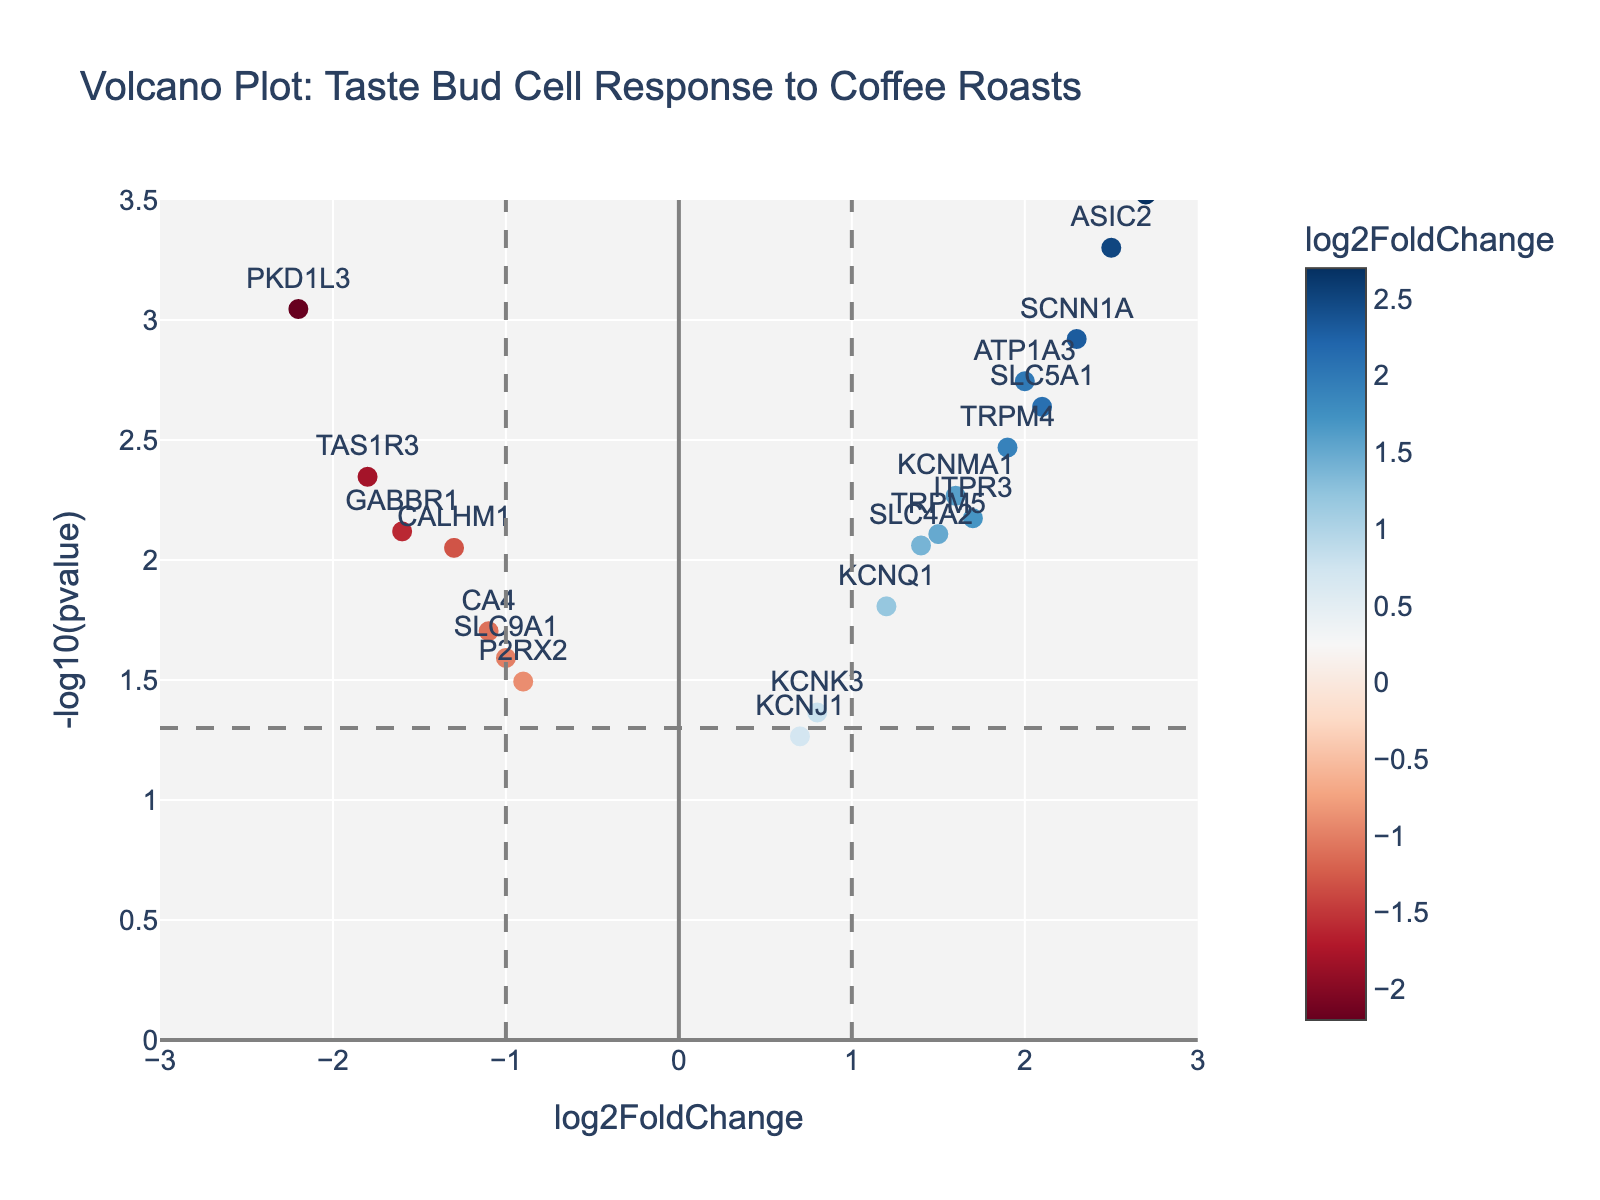what is the title of the plot? The title is usually displayed at the top of the plot and is the text that describes the overall topic or data being visualized.
Answer: Volcano Plot: Taste Bud Cell Response to Coffee Roasts how many genes have a p-value below 0.005? To answer this question, count the data points with -log10(pvalue) greater than log10(0.005), which is approximately 2.3.
Answer: Seven which gene has the highest log2FoldChange? Identify the data point with the highest log2FoldChange value.
Answer: GNAT3 what is the log2FoldChange for gene SCNN1A? Find the data point labeled SCNN1A and read its log2FoldChange value.
Answer: 2.3 what is the significance threshold in terms of -log10(pvalue) depicted by the dashed horizontal line? The dashed horizontal line marks the threshold for statistical significance in a volcano plot. This value corresponds to -log10(0.05).
Answer: 1.3 which genes are downregulated with a p-value less than 0.01? Identify genes with negative log2FoldChange and -log10(pvalue) above 2.
Answer: TAS1R3, PKD1L3, CALHM1, GABBR1 which gene has the most significant change? The most significant change is the gene with the highest -log10(pvalue).
Answer: GNAT3 how many genes have a log2FoldChange greater than 1 and a p-value less than 0.01? Count the data points with log2FoldChange > 1 and -log10(pvalue) > 2.
Answer: Five which gene is closest to the log2FoldChange threshold of -1? Identify the data point with a log2FoldChange value nearest to -1.
Answer: CALHM1 how many genes have -log10(pvalue) between 2 and 3? Count the number of data points with -log10(pvalue) between 2 and 3.
Answer: Eight 